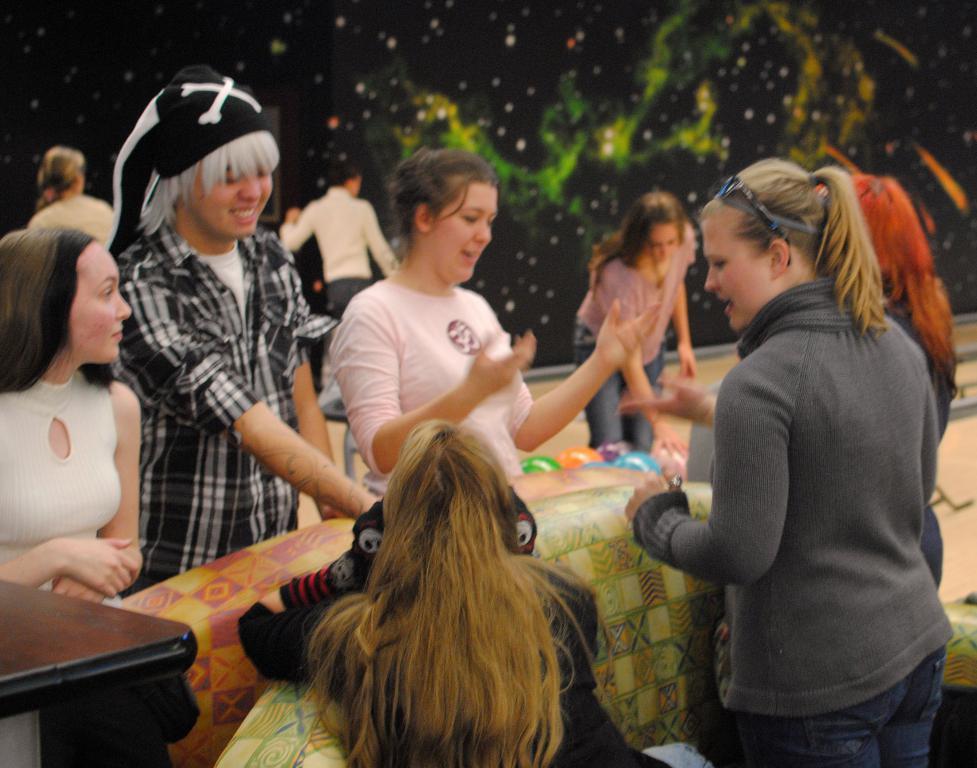How would you summarize this image in a sentence or two? In the image few women are standing and sitting and there are some balloons. In the bottom left corner of the image there is a table. 